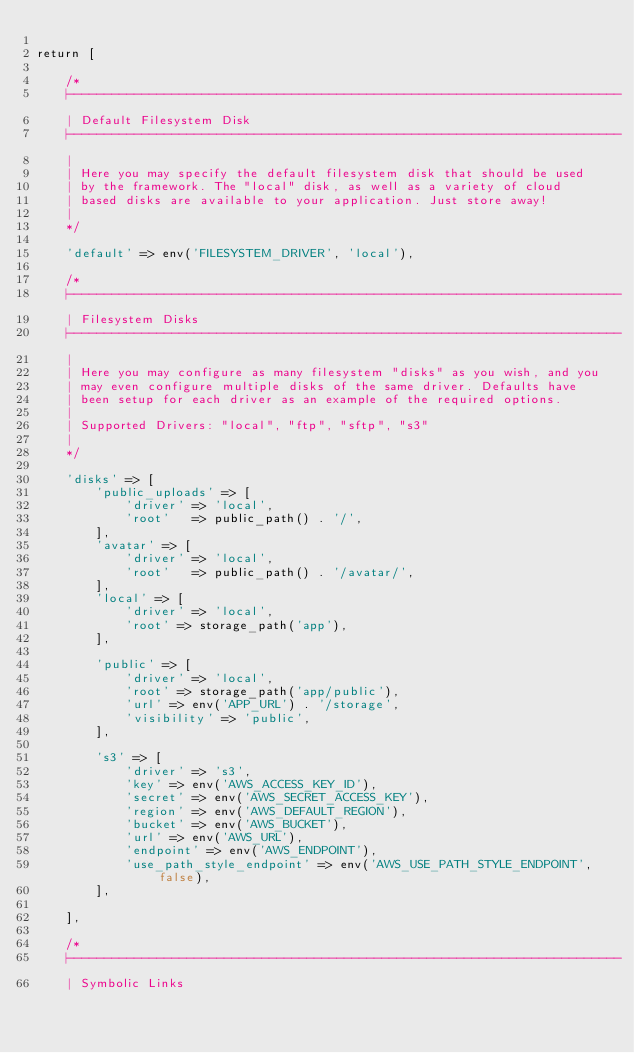Convert code to text. <code><loc_0><loc_0><loc_500><loc_500><_PHP_>
return [

    /*
    |--------------------------------------------------------------------------
    | Default Filesystem Disk
    |--------------------------------------------------------------------------
    |
    | Here you may specify the default filesystem disk that should be used
    | by the framework. The "local" disk, as well as a variety of cloud
    | based disks are available to your application. Just store away!
    |
    */

    'default' => env('FILESYSTEM_DRIVER', 'local'),

    /*
    |--------------------------------------------------------------------------
    | Filesystem Disks
    |--------------------------------------------------------------------------
    |
    | Here you may configure as many filesystem "disks" as you wish, and you
    | may even configure multiple disks of the same driver. Defaults have
    | been setup for each driver as an example of the required options.
    |
    | Supported Drivers: "local", "ftp", "sftp", "s3"
    |
    */

    'disks' => [
        'public_uploads' => [
            'driver' => 'local',
            'root'   => public_path() . '/',
        ],
        'avatar' => [
            'driver' => 'local',
            'root'   => public_path() . '/avatar/',
        ],
        'local' => [
            'driver' => 'local',
            'root' => storage_path('app'),
        ],

        'public' => [
            'driver' => 'local',
            'root' => storage_path('app/public'),
            'url' => env('APP_URL') . '/storage',
            'visibility' => 'public',
        ],

        's3' => [
            'driver' => 's3',
            'key' => env('AWS_ACCESS_KEY_ID'),
            'secret' => env('AWS_SECRET_ACCESS_KEY'),
            'region' => env('AWS_DEFAULT_REGION'),
            'bucket' => env('AWS_BUCKET'),
            'url' => env('AWS_URL'),
            'endpoint' => env('AWS_ENDPOINT'),
            'use_path_style_endpoint' => env('AWS_USE_PATH_STYLE_ENDPOINT', false),
        ],

    ],

    /*
    |--------------------------------------------------------------------------
    | Symbolic Links</code> 